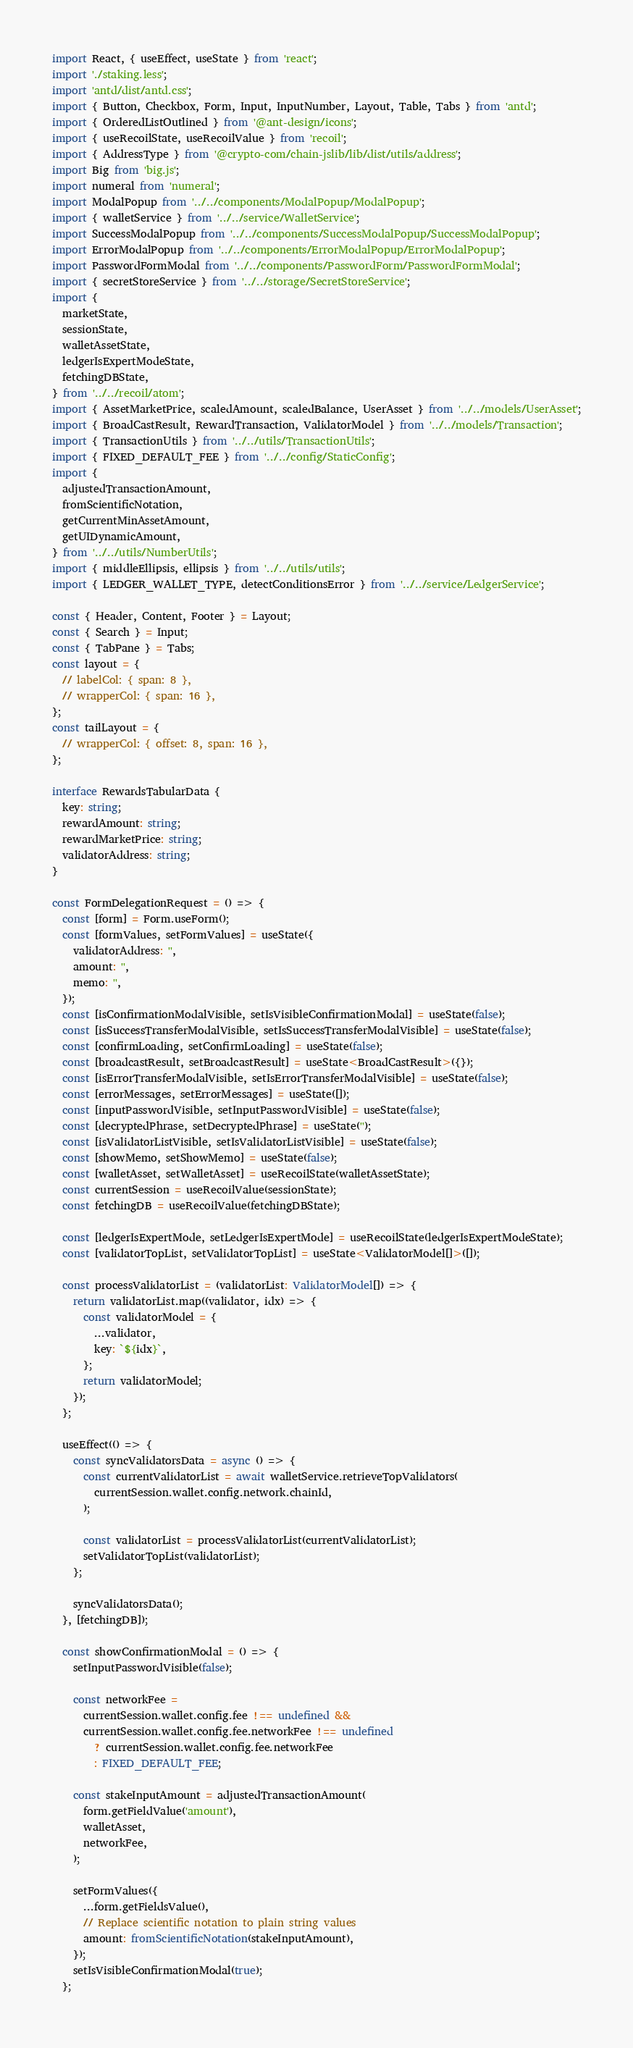<code> <loc_0><loc_0><loc_500><loc_500><_TypeScript_>import React, { useEffect, useState } from 'react';
import './staking.less';
import 'antd/dist/antd.css';
import { Button, Checkbox, Form, Input, InputNumber, Layout, Table, Tabs } from 'antd';
import { OrderedListOutlined } from '@ant-design/icons';
import { useRecoilState, useRecoilValue } from 'recoil';
import { AddressType } from '@crypto-com/chain-jslib/lib/dist/utils/address';
import Big from 'big.js';
import numeral from 'numeral';
import ModalPopup from '../../components/ModalPopup/ModalPopup';
import { walletService } from '../../service/WalletService';
import SuccessModalPopup from '../../components/SuccessModalPopup/SuccessModalPopup';
import ErrorModalPopup from '../../components/ErrorModalPopup/ErrorModalPopup';
import PasswordFormModal from '../../components/PasswordForm/PasswordFormModal';
import { secretStoreService } from '../../storage/SecretStoreService';
import {
  marketState,
  sessionState,
  walletAssetState,
  ledgerIsExpertModeState,
  fetchingDBState,
} from '../../recoil/atom';
import { AssetMarketPrice, scaledAmount, scaledBalance, UserAsset } from '../../models/UserAsset';
import { BroadCastResult, RewardTransaction, ValidatorModel } from '../../models/Transaction';
import { TransactionUtils } from '../../utils/TransactionUtils';
import { FIXED_DEFAULT_FEE } from '../../config/StaticConfig';
import {
  adjustedTransactionAmount,
  fromScientificNotation,
  getCurrentMinAssetAmount,
  getUIDynamicAmount,
} from '../../utils/NumberUtils';
import { middleEllipsis, ellipsis } from '../../utils/utils';
import { LEDGER_WALLET_TYPE, detectConditionsError } from '../../service/LedgerService';

const { Header, Content, Footer } = Layout;
const { Search } = Input;
const { TabPane } = Tabs;
const layout = {
  // labelCol: { span: 8 },
  // wrapperCol: { span: 16 },
};
const tailLayout = {
  // wrapperCol: { offset: 8, span: 16 },
};

interface RewardsTabularData {
  key: string;
  rewardAmount: string;
  rewardMarketPrice: string;
  validatorAddress: string;
}

const FormDelegationRequest = () => {
  const [form] = Form.useForm();
  const [formValues, setFormValues] = useState({
    validatorAddress: '',
    amount: '',
    memo: '',
  });
  const [isConfirmationModalVisible, setIsVisibleConfirmationModal] = useState(false);
  const [isSuccessTransferModalVisible, setIsSuccessTransferModalVisible] = useState(false);
  const [confirmLoading, setConfirmLoading] = useState(false);
  const [broadcastResult, setBroadcastResult] = useState<BroadCastResult>({});
  const [isErrorTransferModalVisible, setIsErrorTransferModalVisible] = useState(false);
  const [errorMessages, setErrorMessages] = useState([]);
  const [inputPasswordVisible, setInputPasswordVisible] = useState(false);
  const [decryptedPhrase, setDecryptedPhrase] = useState('');
  const [isValidatorListVisible, setIsValidatorListVisible] = useState(false);
  const [showMemo, setShowMemo] = useState(false);
  const [walletAsset, setWalletAsset] = useRecoilState(walletAssetState);
  const currentSession = useRecoilValue(sessionState);
  const fetchingDB = useRecoilValue(fetchingDBState);

  const [ledgerIsExpertMode, setLedgerIsExpertMode] = useRecoilState(ledgerIsExpertModeState);
  const [validatorTopList, setValidatorTopList] = useState<ValidatorModel[]>([]);

  const processValidatorList = (validatorList: ValidatorModel[]) => {
    return validatorList.map((validator, idx) => {
      const validatorModel = {
        ...validator,
        key: `${idx}`,
      };
      return validatorModel;
    });
  };

  useEffect(() => {
    const syncValidatorsData = async () => {
      const currentValidatorList = await walletService.retrieveTopValidators(
        currentSession.wallet.config.network.chainId,
      );

      const validatorList = processValidatorList(currentValidatorList);
      setValidatorTopList(validatorList);
    };

    syncValidatorsData();
  }, [fetchingDB]);

  const showConfirmationModal = () => {
    setInputPasswordVisible(false);

    const networkFee =
      currentSession.wallet.config.fee !== undefined &&
      currentSession.wallet.config.fee.networkFee !== undefined
        ? currentSession.wallet.config.fee.networkFee
        : FIXED_DEFAULT_FEE;

    const stakeInputAmount = adjustedTransactionAmount(
      form.getFieldValue('amount'),
      walletAsset,
      networkFee,
    );

    setFormValues({
      ...form.getFieldsValue(),
      // Replace scientific notation to plain string values
      amount: fromScientificNotation(stakeInputAmount),
    });
    setIsVisibleConfirmationModal(true);
  };
</code> 